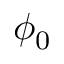Convert formula to latex. <formula><loc_0><loc_0><loc_500><loc_500>\phi _ { 0 }</formula> 